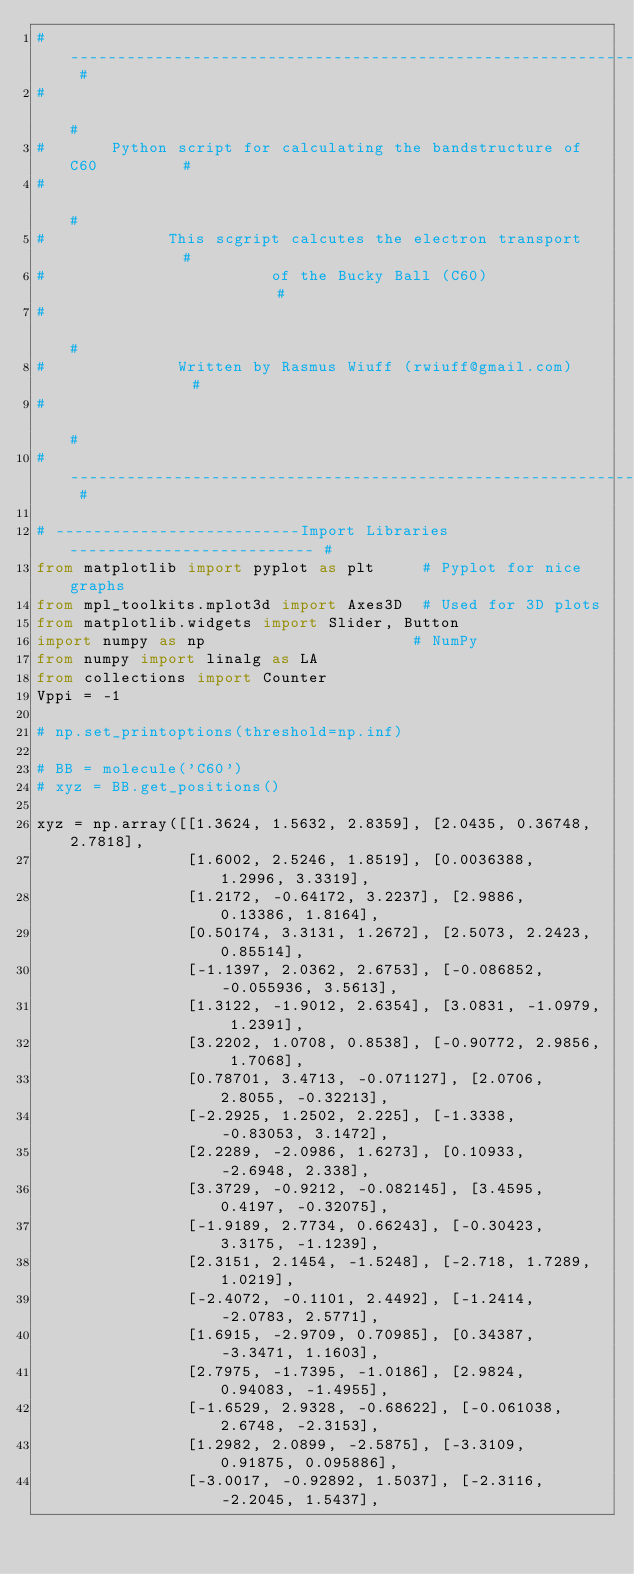<code> <loc_0><loc_0><loc_500><loc_500><_Python_># -------------------------------------------------------------------- #
#                                                                      #
#       Python script for calculating the bandstructure of C60         #
#                                                                      #
#             This scgript calcutes the electron transport             #
#                        of the Bucky Ball (C60)                       #
#                                                                      #
#              Written by Rasmus Wiuff (rwiuff@gmail.com)              #
#                                                                      #
# -------------------------------------------------------------------- #

# --------------------------Import Libraries-------------------------- #
from matplotlib import pyplot as plt     # Pyplot for nice graphs
from mpl_toolkits.mplot3d import Axes3D  # Used for 3D plots
from matplotlib.widgets import Slider, Button
import numpy as np                      # NumPy
from numpy import linalg as LA
from collections import Counter
Vppi = -1

# np.set_printoptions(threshold=np.inf)

# BB = molecule('C60')
# xyz = BB.get_positions()

xyz = np.array([[1.3624, 1.5632, 2.8359], [2.0435, 0.36748, 2.7818],
                [1.6002, 2.5246, 1.8519], [0.0036388, 1.2996, 3.3319],
                [1.2172, -0.64172, 3.2237], [2.9886, 0.13386, 1.8164],
                [0.50174, 3.3131, 1.2672], [2.5073, 2.2423, 0.85514],
                [-1.1397, 2.0362, 2.6753], [-0.086852, -0.055936, 3.5613],
                [1.3122, -1.9012, 2.6354], [3.0831, -1.0979, 1.2391],
                [3.2202, 1.0708, 0.8538], [-0.90772, 2.9856, 1.7068],
                [0.78701, 3.4713, -0.071127], [2.0706, 2.8055, -0.32213],
                [-2.2925, 1.2502, 2.225], [-1.3338, -0.83053, 3.1472],
                [2.2289, -2.0986, 1.6273], [0.10933, -2.6948, 2.338],
                [3.3729, -0.9212, -0.082145], [3.4595, 0.4197, -0.32075],
                [-1.9189, 2.7734, 0.66243], [-0.30423, 3.3175, -1.1239],
                [2.3151, 2.1454, -1.5248], [-2.718, 1.7289, 1.0219],
                [-2.4072, -0.1101, 2.4492], [-1.2414, -2.0783, 2.5771],
                [1.6915, -2.9709, 0.70985], [0.34387, -3.3471, 1.1603],
                [2.7975, -1.7395, -1.0186], [2.9824, 0.94083, -1.4955],
                [-1.6529, 2.9328, -0.68622], [-0.061038, 2.6748, -2.3153],
                [1.2982, 2.0899, -2.5875], [-3.3109, 0.91875, 0.095886],
                [-3.0017, -0.92892, 1.5037], [-2.3116, -2.2045, 1.5437],</code> 